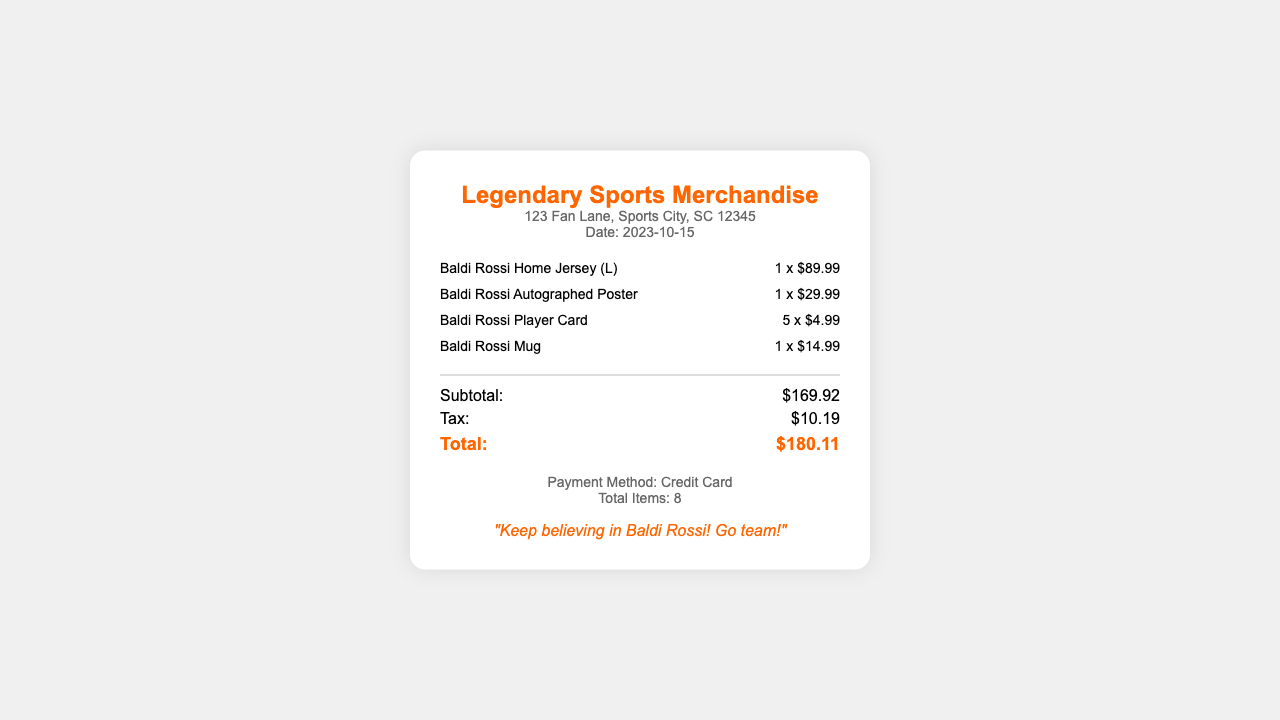What is the store name? The store name is prominently displayed at the top of the receipt.
Answer: Legendary Sports Merchandise What is the purchase date? The purchase date is listed under the store information section.
Answer: 2023-10-15 How many Baldi Rossi Player Cards were purchased? The quantity of Player Cards is shown next to the item description.
Answer: 5 What is the price of the Baldi Rossi Home Jersey? The price of the jersey is indicated next to the item's quantity.
Answer: $89.99 What is the total amount spent? The total is calculated at the bottom of the receipt, summarizing the entire purchase cost.
Answer: $180.11 How much was spent on tax? The tax amount is specified in the summary section of the receipt.
Answer: $10.19 What payment method was used? The payment method is indicated at the bottom of the receipt.
Answer: Credit Card How many total items were purchased? The total number of items is displayed in the footer section of the receipt.
Answer: 8 What is the first item listed on the receipt? The first item listed is mentioned in the items section of the receipt.
Answer: Baldi Rossi Home Jersey (L) 